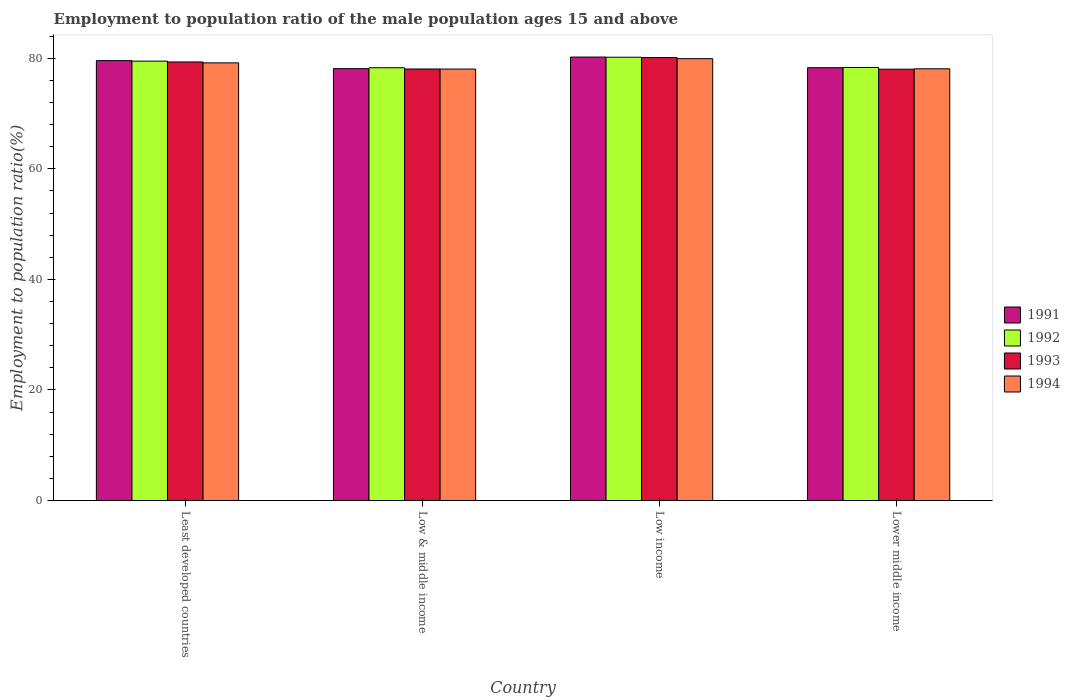Are the number of bars on each tick of the X-axis equal?
Provide a succinct answer. Yes. How many bars are there on the 2nd tick from the left?
Provide a short and direct response. 4. How many bars are there on the 4th tick from the right?
Your response must be concise. 4. What is the label of the 2nd group of bars from the left?
Make the answer very short. Low & middle income. In how many cases, is the number of bars for a given country not equal to the number of legend labels?
Offer a terse response. 0. What is the employment to population ratio in 1991 in Lower middle income?
Offer a terse response. 78.3. Across all countries, what is the maximum employment to population ratio in 1992?
Your answer should be very brief. 80.2. Across all countries, what is the minimum employment to population ratio in 1994?
Ensure brevity in your answer.  78.06. In which country was the employment to population ratio in 1993 minimum?
Give a very brief answer. Lower middle income. What is the total employment to population ratio in 1992 in the graph?
Give a very brief answer. 316.33. What is the difference between the employment to population ratio in 1992 in Low income and that in Lower middle income?
Offer a terse response. 1.86. What is the difference between the employment to population ratio in 1992 in Low & middle income and the employment to population ratio in 1993 in Low income?
Your answer should be very brief. -1.84. What is the average employment to population ratio in 1992 per country?
Make the answer very short. 79.08. What is the difference between the employment to population ratio of/in 1993 and employment to population ratio of/in 1994 in Lower middle income?
Keep it short and to the point. -0.07. What is the ratio of the employment to population ratio in 1993 in Low income to that in Lower middle income?
Your response must be concise. 1.03. What is the difference between the highest and the second highest employment to population ratio in 1993?
Ensure brevity in your answer.  2.06. What is the difference between the highest and the lowest employment to population ratio in 1994?
Your answer should be compact. 1.88. Is the sum of the employment to population ratio in 1993 in Least developed countries and Lower middle income greater than the maximum employment to population ratio in 1994 across all countries?
Your answer should be compact. Yes. Is it the case that in every country, the sum of the employment to population ratio in 1992 and employment to population ratio in 1993 is greater than the sum of employment to population ratio in 1994 and employment to population ratio in 1991?
Keep it short and to the point. No. What does the 4th bar from the left in Least developed countries represents?
Your answer should be very brief. 1994. What does the 3rd bar from the right in Low income represents?
Keep it short and to the point. 1992. Are all the bars in the graph horizontal?
Your response must be concise. No. How many countries are there in the graph?
Offer a terse response. 4. Does the graph contain grids?
Make the answer very short. No. Where does the legend appear in the graph?
Offer a very short reply. Center right. How many legend labels are there?
Make the answer very short. 4. What is the title of the graph?
Offer a very short reply. Employment to population ratio of the male population ages 15 and above. What is the Employment to population ratio(%) of 1991 in Least developed countries?
Give a very brief answer. 79.59. What is the Employment to population ratio(%) in 1992 in Least developed countries?
Your answer should be very brief. 79.49. What is the Employment to population ratio(%) in 1993 in Least developed countries?
Ensure brevity in your answer.  79.34. What is the Employment to population ratio(%) in 1994 in Least developed countries?
Provide a succinct answer. 79.18. What is the Employment to population ratio(%) in 1991 in Low & middle income?
Offer a very short reply. 78.14. What is the Employment to population ratio(%) in 1992 in Low & middle income?
Your answer should be compact. 78.3. What is the Employment to population ratio(%) in 1993 in Low & middle income?
Provide a succinct answer. 78.07. What is the Employment to population ratio(%) of 1994 in Low & middle income?
Offer a terse response. 78.06. What is the Employment to population ratio(%) of 1991 in Low income?
Your answer should be very brief. 80.23. What is the Employment to population ratio(%) of 1992 in Low income?
Your answer should be very brief. 80.2. What is the Employment to population ratio(%) in 1993 in Low income?
Provide a succinct answer. 80.14. What is the Employment to population ratio(%) of 1994 in Low income?
Offer a terse response. 79.94. What is the Employment to population ratio(%) of 1991 in Lower middle income?
Keep it short and to the point. 78.3. What is the Employment to population ratio(%) in 1992 in Lower middle income?
Provide a short and direct response. 78.34. What is the Employment to population ratio(%) in 1993 in Lower middle income?
Keep it short and to the point. 78.04. What is the Employment to population ratio(%) in 1994 in Lower middle income?
Give a very brief answer. 78.11. Across all countries, what is the maximum Employment to population ratio(%) of 1991?
Offer a terse response. 80.23. Across all countries, what is the maximum Employment to population ratio(%) of 1992?
Offer a very short reply. 80.2. Across all countries, what is the maximum Employment to population ratio(%) of 1993?
Your answer should be very brief. 80.14. Across all countries, what is the maximum Employment to population ratio(%) in 1994?
Your answer should be compact. 79.94. Across all countries, what is the minimum Employment to population ratio(%) in 1991?
Your answer should be compact. 78.14. Across all countries, what is the minimum Employment to population ratio(%) of 1992?
Make the answer very short. 78.3. Across all countries, what is the minimum Employment to population ratio(%) in 1993?
Provide a short and direct response. 78.04. Across all countries, what is the minimum Employment to population ratio(%) in 1994?
Provide a short and direct response. 78.06. What is the total Employment to population ratio(%) of 1991 in the graph?
Your response must be concise. 316.26. What is the total Employment to population ratio(%) in 1992 in the graph?
Offer a terse response. 316.33. What is the total Employment to population ratio(%) of 1993 in the graph?
Your answer should be compact. 315.59. What is the total Employment to population ratio(%) of 1994 in the graph?
Give a very brief answer. 315.29. What is the difference between the Employment to population ratio(%) of 1991 in Least developed countries and that in Low & middle income?
Provide a short and direct response. 1.45. What is the difference between the Employment to population ratio(%) of 1992 in Least developed countries and that in Low & middle income?
Give a very brief answer. 1.19. What is the difference between the Employment to population ratio(%) of 1993 in Least developed countries and that in Low & middle income?
Offer a terse response. 1.27. What is the difference between the Employment to population ratio(%) of 1994 in Least developed countries and that in Low & middle income?
Ensure brevity in your answer.  1.12. What is the difference between the Employment to population ratio(%) in 1991 in Least developed countries and that in Low income?
Ensure brevity in your answer.  -0.65. What is the difference between the Employment to population ratio(%) of 1992 in Least developed countries and that in Low income?
Offer a terse response. -0.71. What is the difference between the Employment to population ratio(%) in 1993 in Least developed countries and that in Low income?
Give a very brief answer. -0.79. What is the difference between the Employment to population ratio(%) in 1994 in Least developed countries and that in Low income?
Ensure brevity in your answer.  -0.76. What is the difference between the Employment to population ratio(%) of 1991 in Least developed countries and that in Lower middle income?
Give a very brief answer. 1.28. What is the difference between the Employment to population ratio(%) in 1992 in Least developed countries and that in Lower middle income?
Keep it short and to the point. 1.15. What is the difference between the Employment to population ratio(%) in 1993 in Least developed countries and that in Lower middle income?
Give a very brief answer. 1.31. What is the difference between the Employment to population ratio(%) of 1994 in Least developed countries and that in Lower middle income?
Offer a very short reply. 1.07. What is the difference between the Employment to population ratio(%) of 1991 in Low & middle income and that in Low income?
Your response must be concise. -2.1. What is the difference between the Employment to population ratio(%) in 1992 in Low & middle income and that in Low income?
Offer a very short reply. -1.9. What is the difference between the Employment to population ratio(%) in 1993 in Low & middle income and that in Low income?
Provide a succinct answer. -2.06. What is the difference between the Employment to population ratio(%) of 1994 in Low & middle income and that in Low income?
Give a very brief answer. -1.88. What is the difference between the Employment to population ratio(%) in 1991 in Low & middle income and that in Lower middle income?
Make the answer very short. -0.17. What is the difference between the Employment to population ratio(%) in 1992 in Low & middle income and that in Lower middle income?
Offer a terse response. -0.04. What is the difference between the Employment to population ratio(%) in 1993 in Low & middle income and that in Lower middle income?
Give a very brief answer. 0.04. What is the difference between the Employment to population ratio(%) in 1994 in Low & middle income and that in Lower middle income?
Your response must be concise. -0.04. What is the difference between the Employment to population ratio(%) of 1991 in Low income and that in Lower middle income?
Keep it short and to the point. 1.93. What is the difference between the Employment to population ratio(%) in 1992 in Low income and that in Lower middle income?
Provide a short and direct response. 1.86. What is the difference between the Employment to population ratio(%) in 1993 in Low income and that in Lower middle income?
Ensure brevity in your answer.  2.1. What is the difference between the Employment to population ratio(%) in 1994 in Low income and that in Lower middle income?
Provide a short and direct response. 1.84. What is the difference between the Employment to population ratio(%) in 1991 in Least developed countries and the Employment to population ratio(%) in 1992 in Low & middle income?
Keep it short and to the point. 1.29. What is the difference between the Employment to population ratio(%) in 1991 in Least developed countries and the Employment to population ratio(%) in 1993 in Low & middle income?
Ensure brevity in your answer.  1.51. What is the difference between the Employment to population ratio(%) of 1991 in Least developed countries and the Employment to population ratio(%) of 1994 in Low & middle income?
Offer a terse response. 1.52. What is the difference between the Employment to population ratio(%) in 1992 in Least developed countries and the Employment to population ratio(%) in 1993 in Low & middle income?
Your answer should be very brief. 1.42. What is the difference between the Employment to population ratio(%) in 1992 in Least developed countries and the Employment to population ratio(%) in 1994 in Low & middle income?
Keep it short and to the point. 1.43. What is the difference between the Employment to population ratio(%) of 1993 in Least developed countries and the Employment to population ratio(%) of 1994 in Low & middle income?
Your answer should be very brief. 1.28. What is the difference between the Employment to population ratio(%) in 1991 in Least developed countries and the Employment to population ratio(%) in 1992 in Low income?
Your answer should be very brief. -0.61. What is the difference between the Employment to population ratio(%) of 1991 in Least developed countries and the Employment to population ratio(%) of 1993 in Low income?
Provide a short and direct response. -0.55. What is the difference between the Employment to population ratio(%) in 1991 in Least developed countries and the Employment to population ratio(%) in 1994 in Low income?
Offer a terse response. -0.35. What is the difference between the Employment to population ratio(%) in 1992 in Least developed countries and the Employment to population ratio(%) in 1993 in Low income?
Offer a very short reply. -0.65. What is the difference between the Employment to population ratio(%) of 1992 in Least developed countries and the Employment to population ratio(%) of 1994 in Low income?
Your response must be concise. -0.45. What is the difference between the Employment to population ratio(%) of 1993 in Least developed countries and the Employment to population ratio(%) of 1994 in Low income?
Offer a terse response. -0.6. What is the difference between the Employment to population ratio(%) in 1991 in Least developed countries and the Employment to population ratio(%) in 1992 in Lower middle income?
Ensure brevity in your answer.  1.25. What is the difference between the Employment to population ratio(%) in 1991 in Least developed countries and the Employment to population ratio(%) in 1993 in Lower middle income?
Offer a terse response. 1.55. What is the difference between the Employment to population ratio(%) in 1991 in Least developed countries and the Employment to population ratio(%) in 1994 in Lower middle income?
Make the answer very short. 1.48. What is the difference between the Employment to population ratio(%) in 1992 in Least developed countries and the Employment to population ratio(%) in 1993 in Lower middle income?
Offer a very short reply. 1.45. What is the difference between the Employment to population ratio(%) in 1992 in Least developed countries and the Employment to population ratio(%) in 1994 in Lower middle income?
Offer a terse response. 1.38. What is the difference between the Employment to population ratio(%) of 1993 in Least developed countries and the Employment to population ratio(%) of 1994 in Lower middle income?
Your answer should be very brief. 1.24. What is the difference between the Employment to population ratio(%) of 1991 in Low & middle income and the Employment to population ratio(%) of 1992 in Low income?
Offer a very short reply. -2.06. What is the difference between the Employment to population ratio(%) in 1991 in Low & middle income and the Employment to population ratio(%) in 1993 in Low income?
Your answer should be compact. -2. What is the difference between the Employment to population ratio(%) of 1991 in Low & middle income and the Employment to population ratio(%) of 1994 in Low income?
Give a very brief answer. -1.8. What is the difference between the Employment to population ratio(%) of 1992 in Low & middle income and the Employment to population ratio(%) of 1993 in Low income?
Offer a very short reply. -1.84. What is the difference between the Employment to population ratio(%) of 1992 in Low & middle income and the Employment to population ratio(%) of 1994 in Low income?
Your answer should be very brief. -1.64. What is the difference between the Employment to population ratio(%) of 1993 in Low & middle income and the Employment to population ratio(%) of 1994 in Low income?
Give a very brief answer. -1.87. What is the difference between the Employment to population ratio(%) of 1991 in Low & middle income and the Employment to population ratio(%) of 1992 in Lower middle income?
Your response must be concise. -0.21. What is the difference between the Employment to population ratio(%) of 1991 in Low & middle income and the Employment to population ratio(%) of 1993 in Lower middle income?
Offer a terse response. 0.1. What is the difference between the Employment to population ratio(%) in 1991 in Low & middle income and the Employment to population ratio(%) in 1994 in Lower middle income?
Give a very brief answer. 0.03. What is the difference between the Employment to population ratio(%) in 1992 in Low & middle income and the Employment to population ratio(%) in 1993 in Lower middle income?
Your answer should be very brief. 0.26. What is the difference between the Employment to population ratio(%) in 1992 in Low & middle income and the Employment to population ratio(%) in 1994 in Lower middle income?
Offer a very short reply. 0.19. What is the difference between the Employment to population ratio(%) in 1993 in Low & middle income and the Employment to population ratio(%) in 1994 in Lower middle income?
Provide a short and direct response. -0.03. What is the difference between the Employment to population ratio(%) of 1991 in Low income and the Employment to population ratio(%) of 1992 in Lower middle income?
Provide a succinct answer. 1.89. What is the difference between the Employment to population ratio(%) of 1991 in Low income and the Employment to population ratio(%) of 1993 in Lower middle income?
Provide a succinct answer. 2.2. What is the difference between the Employment to population ratio(%) of 1991 in Low income and the Employment to population ratio(%) of 1994 in Lower middle income?
Keep it short and to the point. 2.13. What is the difference between the Employment to population ratio(%) in 1992 in Low income and the Employment to population ratio(%) in 1993 in Lower middle income?
Your response must be concise. 2.16. What is the difference between the Employment to population ratio(%) in 1992 in Low income and the Employment to population ratio(%) in 1994 in Lower middle income?
Your response must be concise. 2.1. What is the difference between the Employment to population ratio(%) of 1993 in Low income and the Employment to population ratio(%) of 1994 in Lower middle income?
Your answer should be compact. 2.03. What is the average Employment to population ratio(%) of 1991 per country?
Give a very brief answer. 79.07. What is the average Employment to population ratio(%) of 1992 per country?
Provide a succinct answer. 79.08. What is the average Employment to population ratio(%) of 1993 per country?
Your response must be concise. 78.9. What is the average Employment to population ratio(%) in 1994 per country?
Offer a very short reply. 78.82. What is the difference between the Employment to population ratio(%) in 1991 and Employment to population ratio(%) in 1992 in Least developed countries?
Your answer should be compact. 0.1. What is the difference between the Employment to population ratio(%) of 1991 and Employment to population ratio(%) of 1993 in Least developed countries?
Offer a very short reply. 0.24. What is the difference between the Employment to population ratio(%) of 1991 and Employment to population ratio(%) of 1994 in Least developed countries?
Make the answer very short. 0.41. What is the difference between the Employment to population ratio(%) of 1992 and Employment to population ratio(%) of 1993 in Least developed countries?
Provide a succinct answer. 0.15. What is the difference between the Employment to population ratio(%) of 1992 and Employment to population ratio(%) of 1994 in Least developed countries?
Make the answer very short. 0.31. What is the difference between the Employment to population ratio(%) in 1993 and Employment to population ratio(%) in 1994 in Least developed countries?
Offer a terse response. 0.17. What is the difference between the Employment to population ratio(%) in 1991 and Employment to population ratio(%) in 1992 in Low & middle income?
Give a very brief answer. -0.16. What is the difference between the Employment to population ratio(%) of 1991 and Employment to population ratio(%) of 1993 in Low & middle income?
Offer a terse response. 0.06. What is the difference between the Employment to population ratio(%) in 1991 and Employment to population ratio(%) in 1994 in Low & middle income?
Provide a short and direct response. 0.07. What is the difference between the Employment to population ratio(%) in 1992 and Employment to population ratio(%) in 1993 in Low & middle income?
Your answer should be compact. 0.22. What is the difference between the Employment to population ratio(%) of 1992 and Employment to population ratio(%) of 1994 in Low & middle income?
Give a very brief answer. 0.23. What is the difference between the Employment to population ratio(%) of 1993 and Employment to population ratio(%) of 1994 in Low & middle income?
Offer a very short reply. 0.01. What is the difference between the Employment to population ratio(%) in 1991 and Employment to population ratio(%) in 1992 in Low income?
Ensure brevity in your answer.  0.03. What is the difference between the Employment to population ratio(%) of 1991 and Employment to population ratio(%) of 1993 in Low income?
Offer a very short reply. 0.1. What is the difference between the Employment to population ratio(%) of 1991 and Employment to population ratio(%) of 1994 in Low income?
Provide a succinct answer. 0.29. What is the difference between the Employment to population ratio(%) of 1992 and Employment to population ratio(%) of 1993 in Low income?
Provide a short and direct response. 0.06. What is the difference between the Employment to population ratio(%) of 1992 and Employment to population ratio(%) of 1994 in Low income?
Your answer should be compact. 0.26. What is the difference between the Employment to population ratio(%) of 1993 and Employment to population ratio(%) of 1994 in Low income?
Your answer should be compact. 0.19. What is the difference between the Employment to population ratio(%) of 1991 and Employment to population ratio(%) of 1992 in Lower middle income?
Your response must be concise. -0.04. What is the difference between the Employment to population ratio(%) of 1991 and Employment to population ratio(%) of 1993 in Lower middle income?
Your response must be concise. 0.27. What is the difference between the Employment to population ratio(%) of 1991 and Employment to population ratio(%) of 1994 in Lower middle income?
Make the answer very short. 0.2. What is the difference between the Employment to population ratio(%) in 1992 and Employment to population ratio(%) in 1993 in Lower middle income?
Ensure brevity in your answer.  0.3. What is the difference between the Employment to population ratio(%) of 1992 and Employment to population ratio(%) of 1994 in Lower middle income?
Your answer should be very brief. 0.24. What is the difference between the Employment to population ratio(%) in 1993 and Employment to population ratio(%) in 1994 in Lower middle income?
Offer a terse response. -0.07. What is the ratio of the Employment to population ratio(%) in 1991 in Least developed countries to that in Low & middle income?
Offer a very short reply. 1.02. What is the ratio of the Employment to population ratio(%) of 1992 in Least developed countries to that in Low & middle income?
Your answer should be very brief. 1.02. What is the ratio of the Employment to population ratio(%) in 1993 in Least developed countries to that in Low & middle income?
Keep it short and to the point. 1.02. What is the ratio of the Employment to population ratio(%) of 1994 in Least developed countries to that in Low & middle income?
Offer a very short reply. 1.01. What is the ratio of the Employment to population ratio(%) of 1993 in Least developed countries to that in Low income?
Your response must be concise. 0.99. What is the ratio of the Employment to population ratio(%) of 1991 in Least developed countries to that in Lower middle income?
Provide a succinct answer. 1.02. What is the ratio of the Employment to population ratio(%) in 1992 in Least developed countries to that in Lower middle income?
Ensure brevity in your answer.  1.01. What is the ratio of the Employment to population ratio(%) of 1993 in Least developed countries to that in Lower middle income?
Provide a short and direct response. 1.02. What is the ratio of the Employment to population ratio(%) in 1994 in Least developed countries to that in Lower middle income?
Provide a short and direct response. 1.01. What is the ratio of the Employment to population ratio(%) of 1991 in Low & middle income to that in Low income?
Keep it short and to the point. 0.97. What is the ratio of the Employment to population ratio(%) in 1992 in Low & middle income to that in Low income?
Your answer should be very brief. 0.98. What is the ratio of the Employment to population ratio(%) of 1993 in Low & middle income to that in Low income?
Give a very brief answer. 0.97. What is the ratio of the Employment to population ratio(%) in 1994 in Low & middle income to that in Low income?
Provide a short and direct response. 0.98. What is the ratio of the Employment to population ratio(%) in 1991 in Low & middle income to that in Lower middle income?
Provide a short and direct response. 1. What is the ratio of the Employment to population ratio(%) of 1992 in Low & middle income to that in Lower middle income?
Your answer should be compact. 1. What is the ratio of the Employment to population ratio(%) of 1993 in Low & middle income to that in Lower middle income?
Keep it short and to the point. 1. What is the ratio of the Employment to population ratio(%) in 1991 in Low income to that in Lower middle income?
Provide a short and direct response. 1.02. What is the ratio of the Employment to population ratio(%) of 1992 in Low income to that in Lower middle income?
Provide a short and direct response. 1.02. What is the ratio of the Employment to population ratio(%) in 1993 in Low income to that in Lower middle income?
Offer a terse response. 1.03. What is the ratio of the Employment to population ratio(%) in 1994 in Low income to that in Lower middle income?
Ensure brevity in your answer.  1.02. What is the difference between the highest and the second highest Employment to population ratio(%) in 1991?
Keep it short and to the point. 0.65. What is the difference between the highest and the second highest Employment to population ratio(%) of 1992?
Keep it short and to the point. 0.71. What is the difference between the highest and the second highest Employment to population ratio(%) in 1993?
Ensure brevity in your answer.  0.79. What is the difference between the highest and the second highest Employment to population ratio(%) of 1994?
Ensure brevity in your answer.  0.76. What is the difference between the highest and the lowest Employment to population ratio(%) of 1991?
Offer a very short reply. 2.1. What is the difference between the highest and the lowest Employment to population ratio(%) in 1992?
Give a very brief answer. 1.9. What is the difference between the highest and the lowest Employment to population ratio(%) in 1993?
Give a very brief answer. 2.1. What is the difference between the highest and the lowest Employment to population ratio(%) in 1994?
Offer a very short reply. 1.88. 